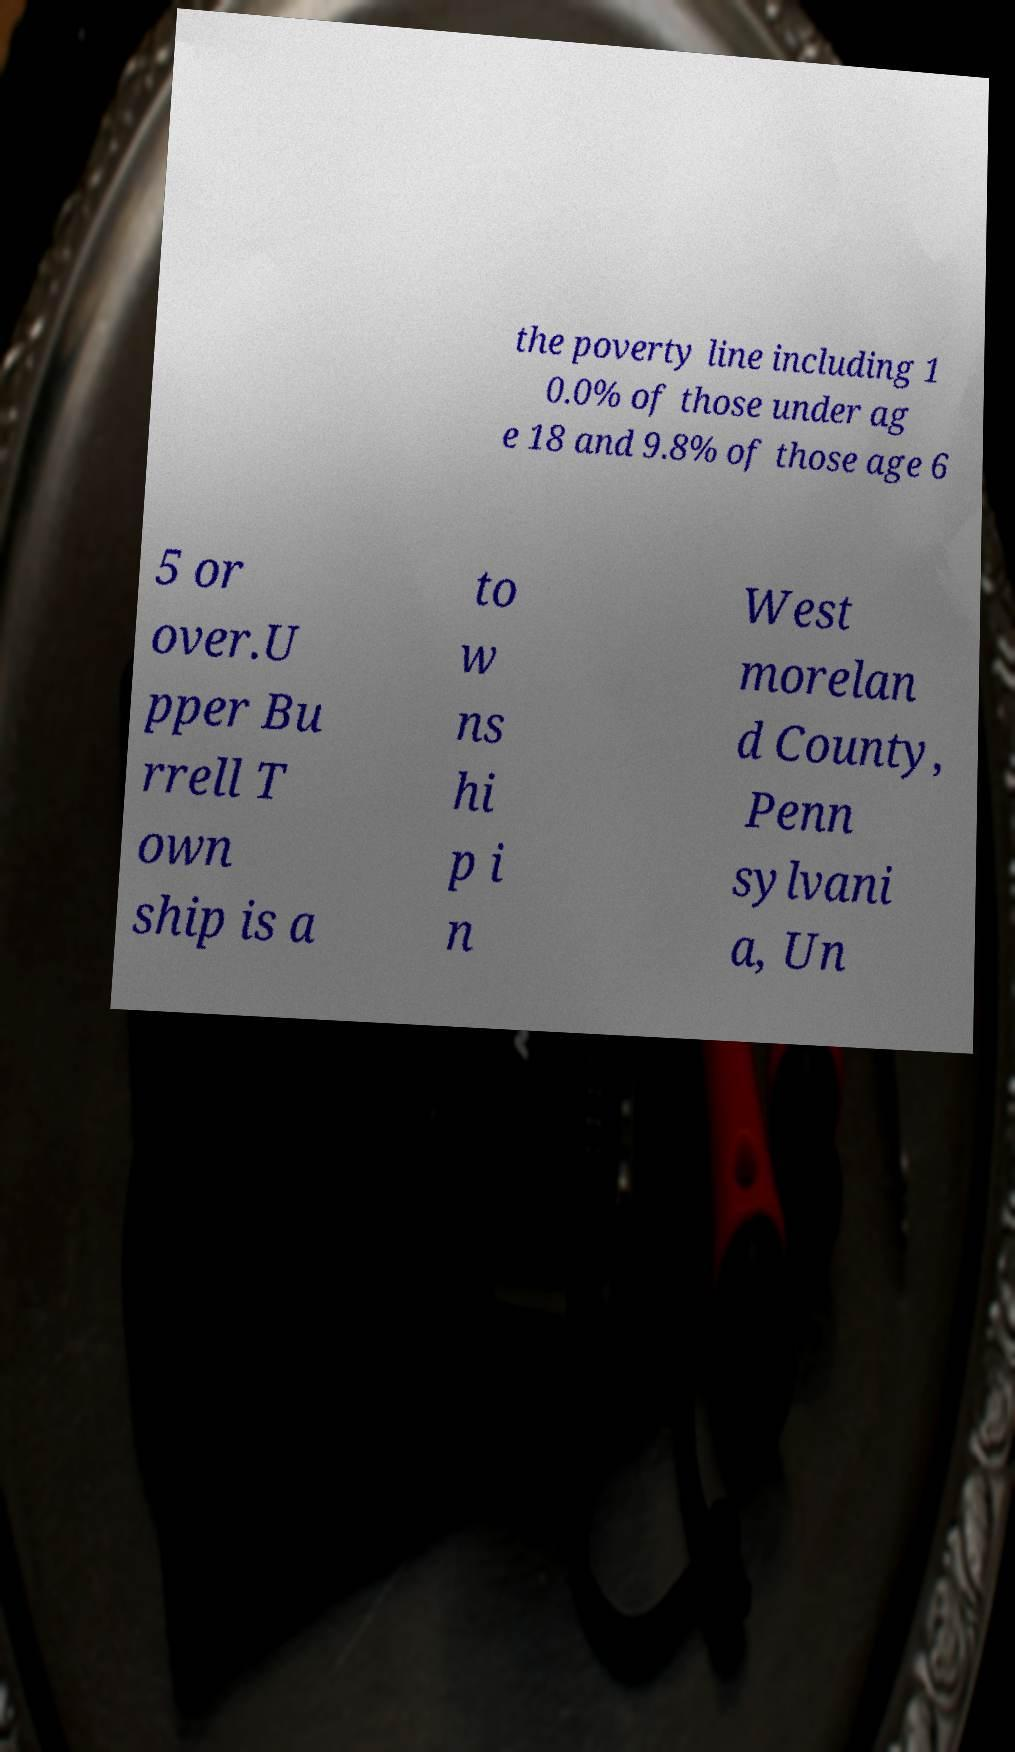There's text embedded in this image that I need extracted. Can you transcribe it verbatim? the poverty line including 1 0.0% of those under ag e 18 and 9.8% of those age 6 5 or over.U pper Bu rrell T own ship is a to w ns hi p i n West morelan d County, Penn sylvani a, Un 